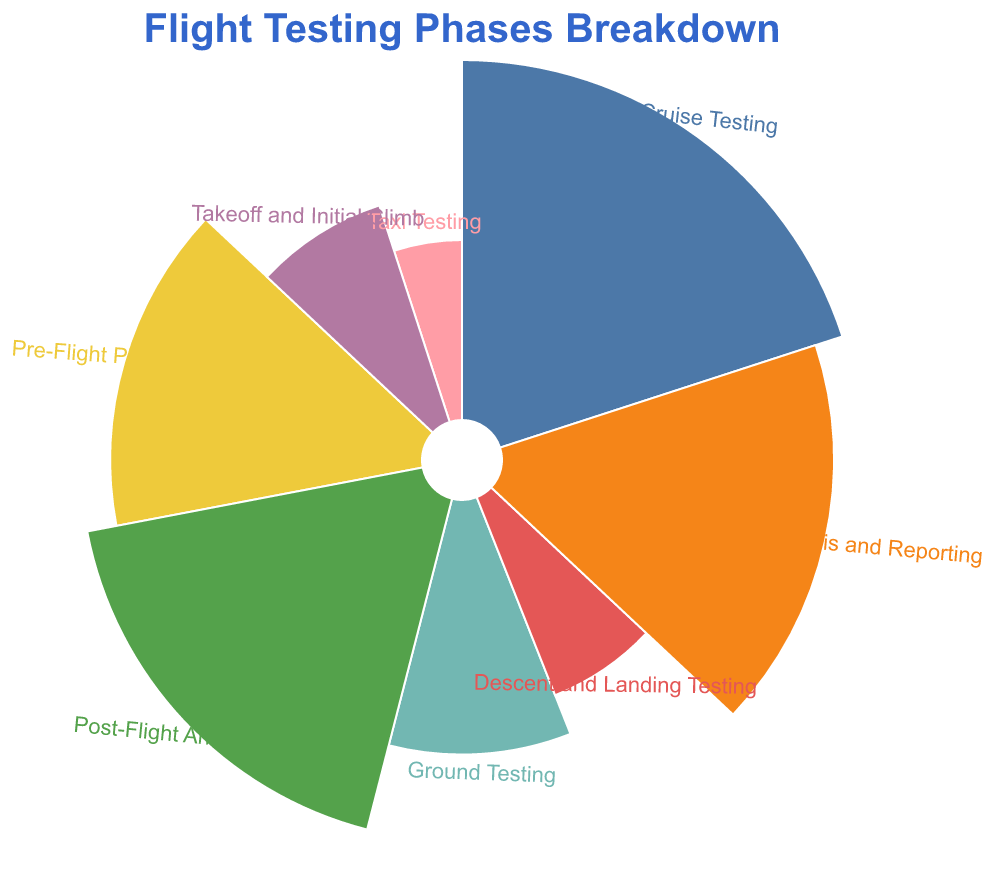What's the title of the chart? The title of the chart is located at the top and reads "Flight Testing Phases Breakdown."
Answer: Flight Testing Phases Breakdown Which flight testing phase has the highest percentage? To find the phase with the highest percentage, locate the segment with the largest value. This is "Cruise Testing" at 20%.
Answer: Cruise Testing What is the combined percentage of Pre-Flight Planning and Post-Flight Analysis? Add the percentages for Pre-Flight Planning (15%) and Post-Flight Analysis (18%). 15% + 18% = 33%.
Answer: 33% How does Ground Testing compare to Taxi Testing in terms of percentage spent? Compare the percentages for both phases. Ground Testing has 10% and Taxi Testing has 5%. Ground Testing has a higher percentage by 5%.
Answer: Ground Testing has 5% more What's the smallest percentage and which phase does it correspond to? Identify the smallest number in the dataset which is 5% corresponding to the "Taxi Testing" phase.
Answer: Taxi Testing What is the sum of Cruise Testing and Data Analysis and Reporting phases? Add the percentages for Cruise Testing (20%) and Data Analysis and Reporting (17%). 20% + 17% = 37%.
Answer: 37% Is the percentage of Post-Flight Analysis higher than Pre-Flight Planning? Compare the percentages for both phases. Post-Flight Analysis is 18% and Pre-Flight Planning is 15%. Yes, Post-Flight Analysis is higher by 3%.
Answer: Yes, by 3% What phase corresponds to the percentage of 8%? Look for the phase with an 8% segment which is "Takeoff and Initial Climb."
Answer: Takeoff and Initial Climb Which phases combined make up half of the total time (50%)? To find a combination that makes 50%, try Cruise Testing (20%), Data Analysis and Reporting (17%), and Ground Testing (10%) giving a total of 47%. Since this does not make exactly 50%, we need to include segments to reach closer combined percentages like Pre-Flight Planning (15%), Post-Flight Analysis (18%), and Data Analysis and Reporting (17%). 15% + 18% + 17% = 50%.
Answer: Pre-Flight Planning, Post-Flight Analysis, and Data Analysis and Reporting What's the difference in percentage between Descent and Landing Testing and Taxi Testing? Subtract the percentage of Taxi Testing (5%) from Descent and Landing Testing (7%). 7% - 5% = 2%.
Answer: 2% 